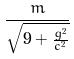<formula> <loc_0><loc_0><loc_500><loc_500>\frac { m } { \sqrt { 9 + \frac { g ^ { 2 } } { c ^ { 2 } } } }</formula> 